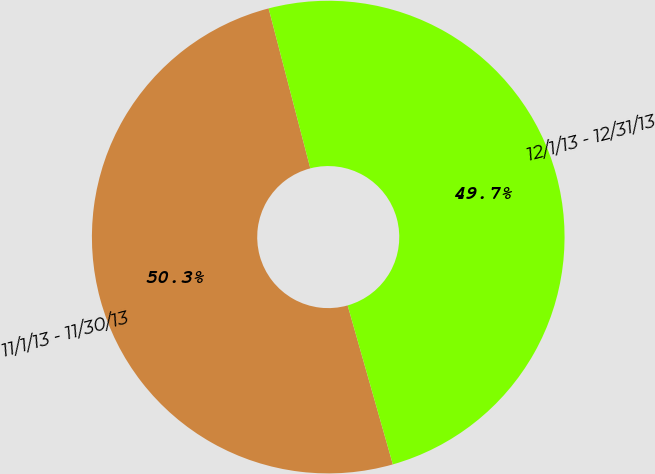Convert chart. <chart><loc_0><loc_0><loc_500><loc_500><pie_chart><fcel>11/1/13 - 11/30/13<fcel>12/1/13 - 12/31/13<nl><fcel>50.35%<fcel>49.65%<nl></chart> 